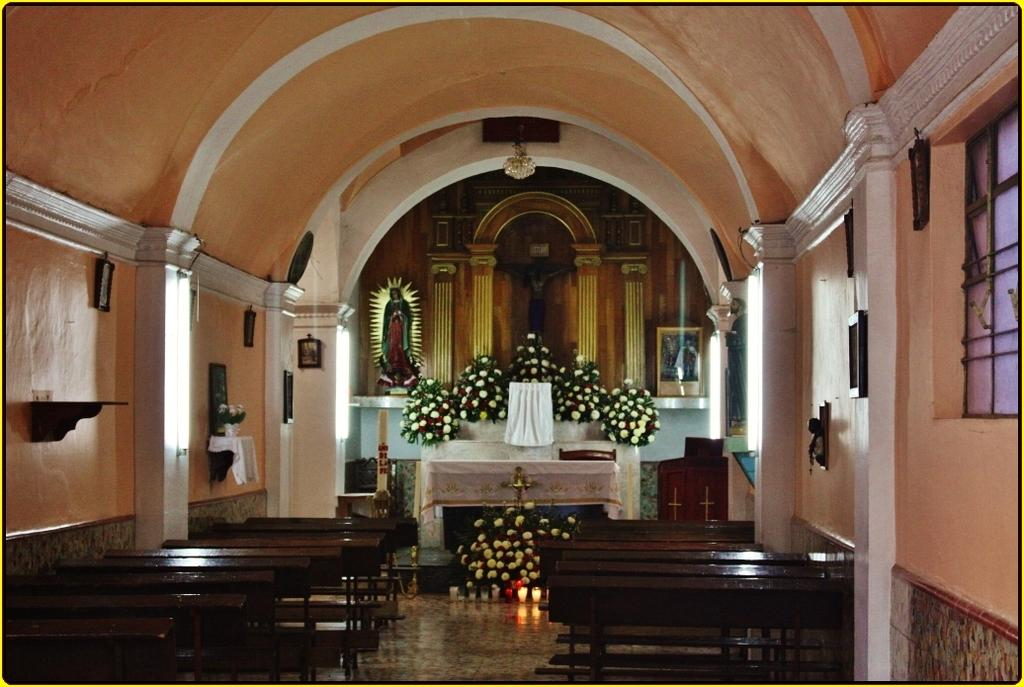What type of furniture is present in the image? There are benches in the image. What part of the room can be seen in the image? The floor is visible in the image. What architectural feature is present in the image? There is a window in the image. What decorative items can be seen in the background of the image? In the background of the image, there are flower bouquets, clothes, candles, statues, a table, frames, and various objects. Can you tell me the name of the guide who is leading the tour in the image? There is no guide present in the image. What type of tools does the carpenter use in the image? There is no carpenter present in the image. 